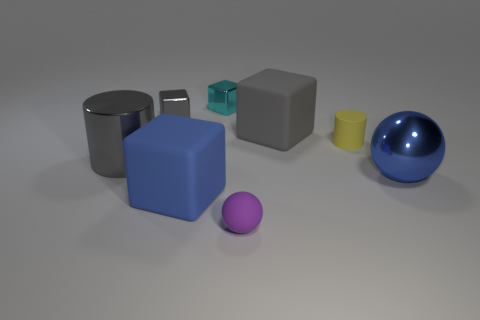How many matte spheres are right of the gray thing that is on the right side of the matte block to the left of the small cyan thing?
Provide a short and direct response. 0. Are there any other things that are the same color as the matte sphere?
Your response must be concise. No. What number of small objects are right of the gray metallic cube and behind the tiny purple sphere?
Your answer should be compact. 2. There is a blue sphere to the right of the small purple object; does it have the same size as the cube in front of the gray cylinder?
Your answer should be compact. Yes. How many things are matte things behind the blue shiny sphere or big metallic objects?
Provide a succinct answer. 4. What is the cylinder that is on the left side of the tiny purple sphere made of?
Offer a terse response. Metal. What is the large cylinder made of?
Give a very brief answer. Metal. The large thing behind the tiny rubber object that is behind the blue thing that is left of the yellow matte cylinder is made of what material?
Make the answer very short. Rubber. There is a purple rubber ball; is it the same size as the gray shiny thing behind the small yellow object?
Provide a succinct answer. Yes. How many things are either cubes in front of the blue sphere or large cubes in front of the tiny yellow cylinder?
Make the answer very short. 1. 